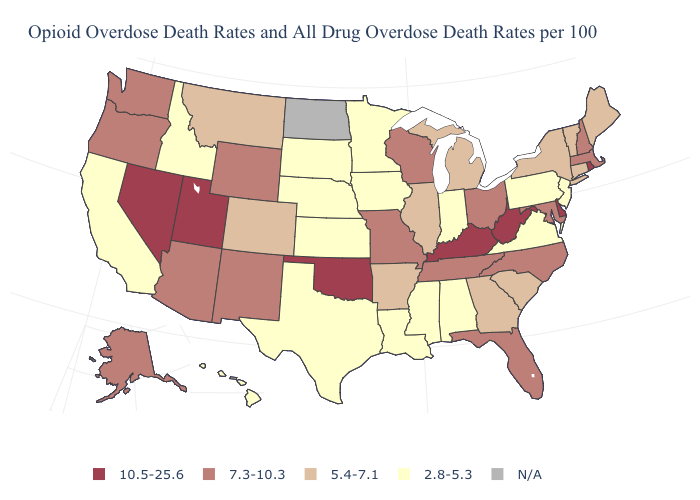What is the highest value in the USA?
Be succinct. 10.5-25.6. Is the legend a continuous bar?
Give a very brief answer. No. Which states have the lowest value in the USA?
Give a very brief answer. Alabama, California, Hawaii, Idaho, Indiana, Iowa, Kansas, Louisiana, Minnesota, Mississippi, Nebraska, New Jersey, Pennsylvania, South Dakota, Texas, Virginia. Does the map have missing data?
Short answer required. Yes. What is the highest value in the West ?
Keep it brief. 10.5-25.6. Name the states that have a value in the range 2.8-5.3?
Answer briefly. Alabama, California, Hawaii, Idaho, Indiana, Iowa, Kansas, Louisiana, Minnesota, Mississippi, Nebraska, New Jersey, Pennsylvania, South Dakota, Texas, Virginia. Which states have the lowest value in the USA?
Concise answer only. Alabama, California, Hawaii, Idaho, Indiana, Iowa, Kansas, Louisiana, Minnesota, Mississippi, Nebraska, New Jersey, Pennsylvania, South Dakota, Texas, Virginia. Which states have the lowest value in the South?
Be succinct. Alabama, Louisiana, Mississippi, Texas, Virginia. What is the lowest value in the MidWest?
Concise answer only. 2.8-5.3. What is the highest value in the USA?
Short answer required. 10.5-25.6. Among the states that border Utah , which have the highest value?
Give a very brief answer. Nevada. Name the states that have a value in the range N/A?
Short answer required. North Dakota. What is the lowest value in states that border Florida?
Short answer required. 2.8-5.3. 